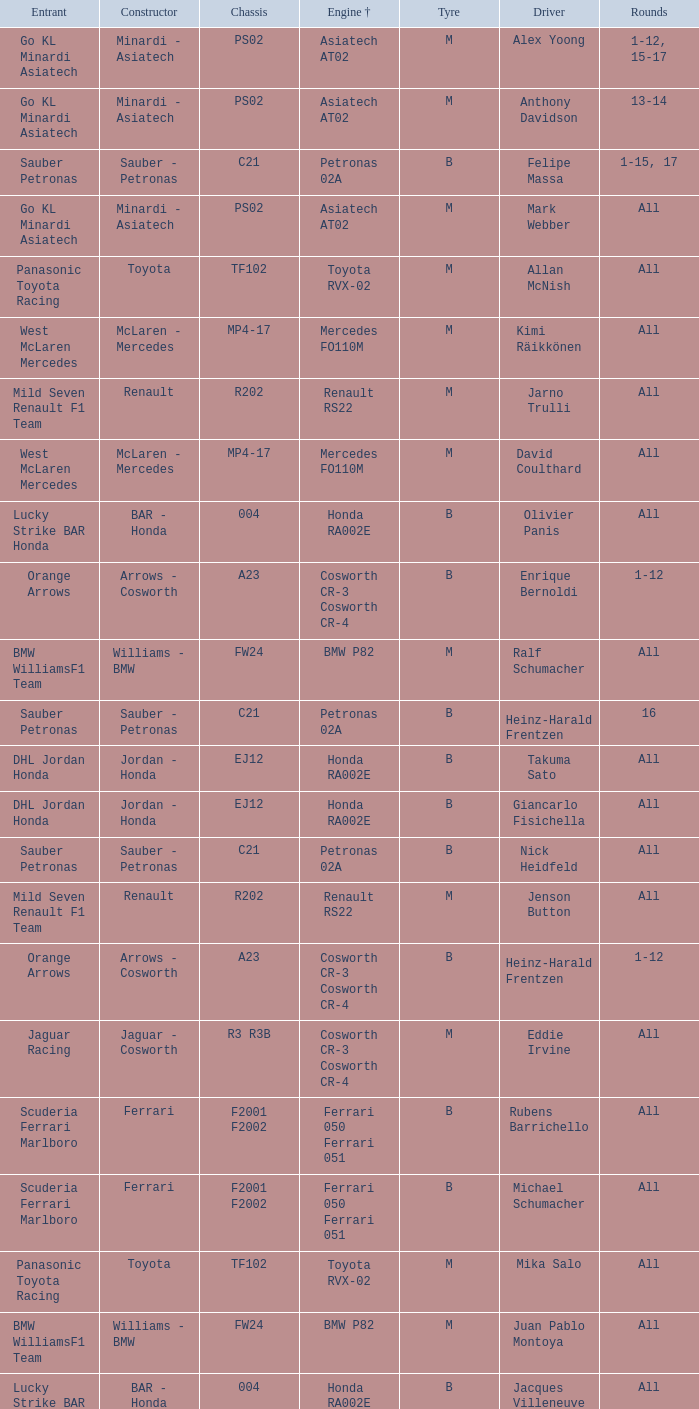Give me the full table as a dictionary. {'header': ['Entrant', 'Constructor', 'Chassis', 'Engine †', 'Tyre', 'Driver', 'Rounds'], 'rows': [['Go KL Minardi Asiatech', 'Minardi - Asiatech', 'PS02', 'Asiatech AT02', 'M', 'Alex Yoong', '1-12, 15-17'], ['Go KL Minardi Asiatech', 'Minardi - Asiatech', 'PS02', 'Asiatech AT02', 'M', 'Anthony Davidson', '13-14'], ['Sauber Petronas', 'Sauber - Petronas', 'C21', 'Petronas 02A', 'B', 'Felipe Massa', '1-15, 17'], ['Go KL Minardi Asiatech', 'Minardi - Asiatech', 'PS02', 'Asiatech AT02', 'M', 'Mark Webber', 'All'], ['Panasonic Toyota Racing', 'Toyota', 'TF102', 'Toyota RVX-02', 'M', 'Allan McNish', 'All'], ['West McLaren Mercedes', 'McLaren - Mercedes', 'MP4-17', 'Mercedes FO110M', 'M', 'Kimi Räikkönen', 'All'], ['Mild Seven Renault F1 Team', 'Renault', 'R202', 'Renault RS22', 'M', 'Jarno Trulli', 'All'], ['West McLaren Mercedes', 'McLaren - Mercedes', 'MP4-17', 'Mercedes FO110M', 'M', 'David Coulthard', 'All'], ['Lucky Strike BAR Honda', 'BAR - Honda', '004', 'Honda RA002E', 'B', 'Olivier Panis', 'All'], ['Orange Arrows', 'Arrows - Cosworth', 'A23', 'Cosworth CR-3 Cosworth CR-4', 'B', 'Enrique Bernoldi', '1-12'], ['BMW WilliamsF1 Team', 'Williams - BMW', 'FW24', 'BMW P82', 'M', 'Ralf Schumacher', 'All'], ['Sauber Petronas', 'Sauber - Petronas', 'C21', 'Petronas 02A', 'B', 'Heinz-Harald Frentzen', '16'], ['DHL Jordan Honda', 'Jordan - Honda', 'EJ12', 'Honda RA002E', 'B', 'Takuma Sato', 'All'], ['DHL Jordan Honda', 'Jordan - Honda', 'EJ12', 'Honda RA002E', 'B', 'Giancarlo Fisichella', 'All'], ['Sauber Petronas', 'Sauber - Petronas', 'C21', 'Petronas 02A', 'B', 'Nick Heidfeld', 'All'], ['Mild Seven Renault F1 Team', 'Renault', 'R202', 'Renault RS22', 'M', 'Jenson Button', 'All'], ['Orange Arrows', 'Arrows - Cosworth', 'A23', 'Cosworth CR-3 Cosworth CR-4', 'B', 'Heinz-Harald Frentzen', '1-12'], ['Jaguar Racing', 'Jaguar - Cosworth', 'R3 R3B', 'Cosworth CR-3 Cosworth CR-4', 'M', 'Eddie Irvine', 'All'], ['Scuderia Ferrari Marlboro', 'Ferrari', 'F2001 F2002', 'Ferrari 050 Ferrari 051', 'B', 'Rubens Barrichello', 'All'], ['Scuderia Ferrari Marlboro', 'Ferrari', 'F2001 F2002', 'Ferrari 050 Ferrari 051', 'B', 'Michael Schumacher', 'All'], ['Panasonic Toyota Racing', 'Toyota', 'TF102', 'Toyota RVX-02', 'M', 'Mika Salo', 'All'], ['BMW WilliamsF1 Team', 'Williams - BMW', 'FW24', 'BMW P82', 'M', 'Juan Pablo Montoya', 'All'], ['Lucky Strike BAR Honda', 'BAR - Honda', '004', 'Honda RA002E', 'B', 'Jacques Villeneuve', 'All'], ['Jaguar Racing', 'Jaguar - Cosworth', 'R3 R3B', 'Cosworth CR-3 Cosworth CR-4', 'M', 'Pedro de la Rosa', 'All']]} What is the chassis when the tyre is b, the engine is ferrari 050 ferrari 051 and the driver is rubens barrichello? F2001 F2002. 